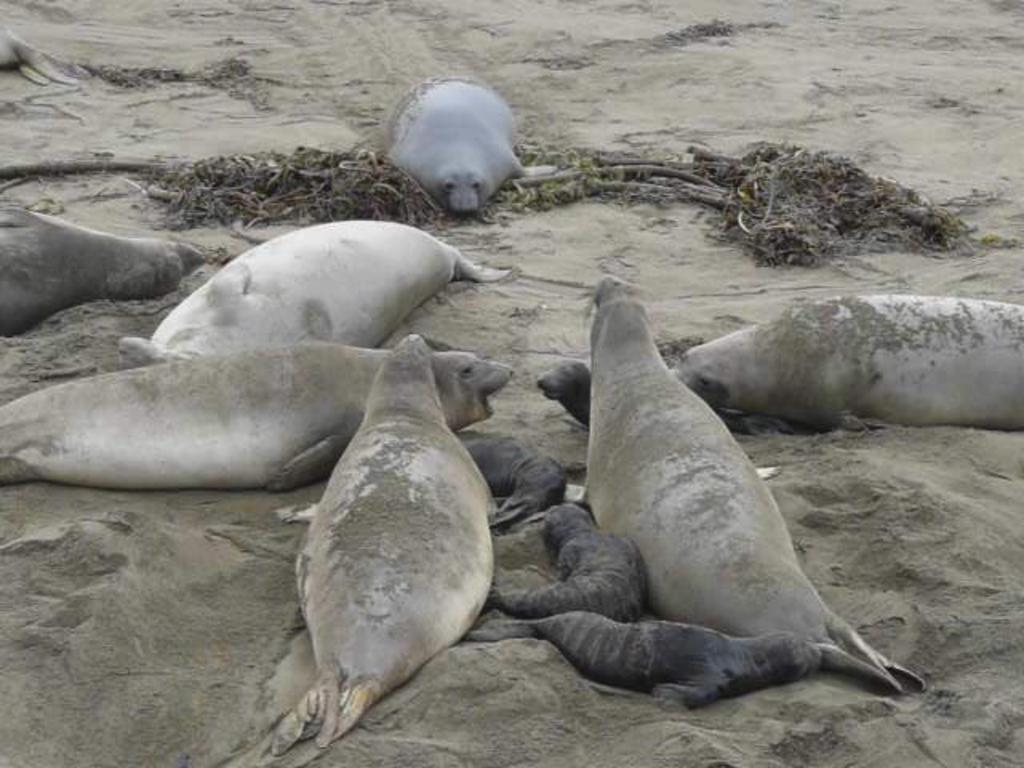What type of animals are in the image? There are seals in the image. Are there any specific types of seals in the image? Yes, there are baby seals in the image. Where are the seals and baby seals located? The seals and baby seals are on the sand. What type of hammer can be seen in the image? There is no hammer present in the image. Are there any snakes visible in the image? No, there are no snakes in the image; it features seals and baby seals on the sand. 